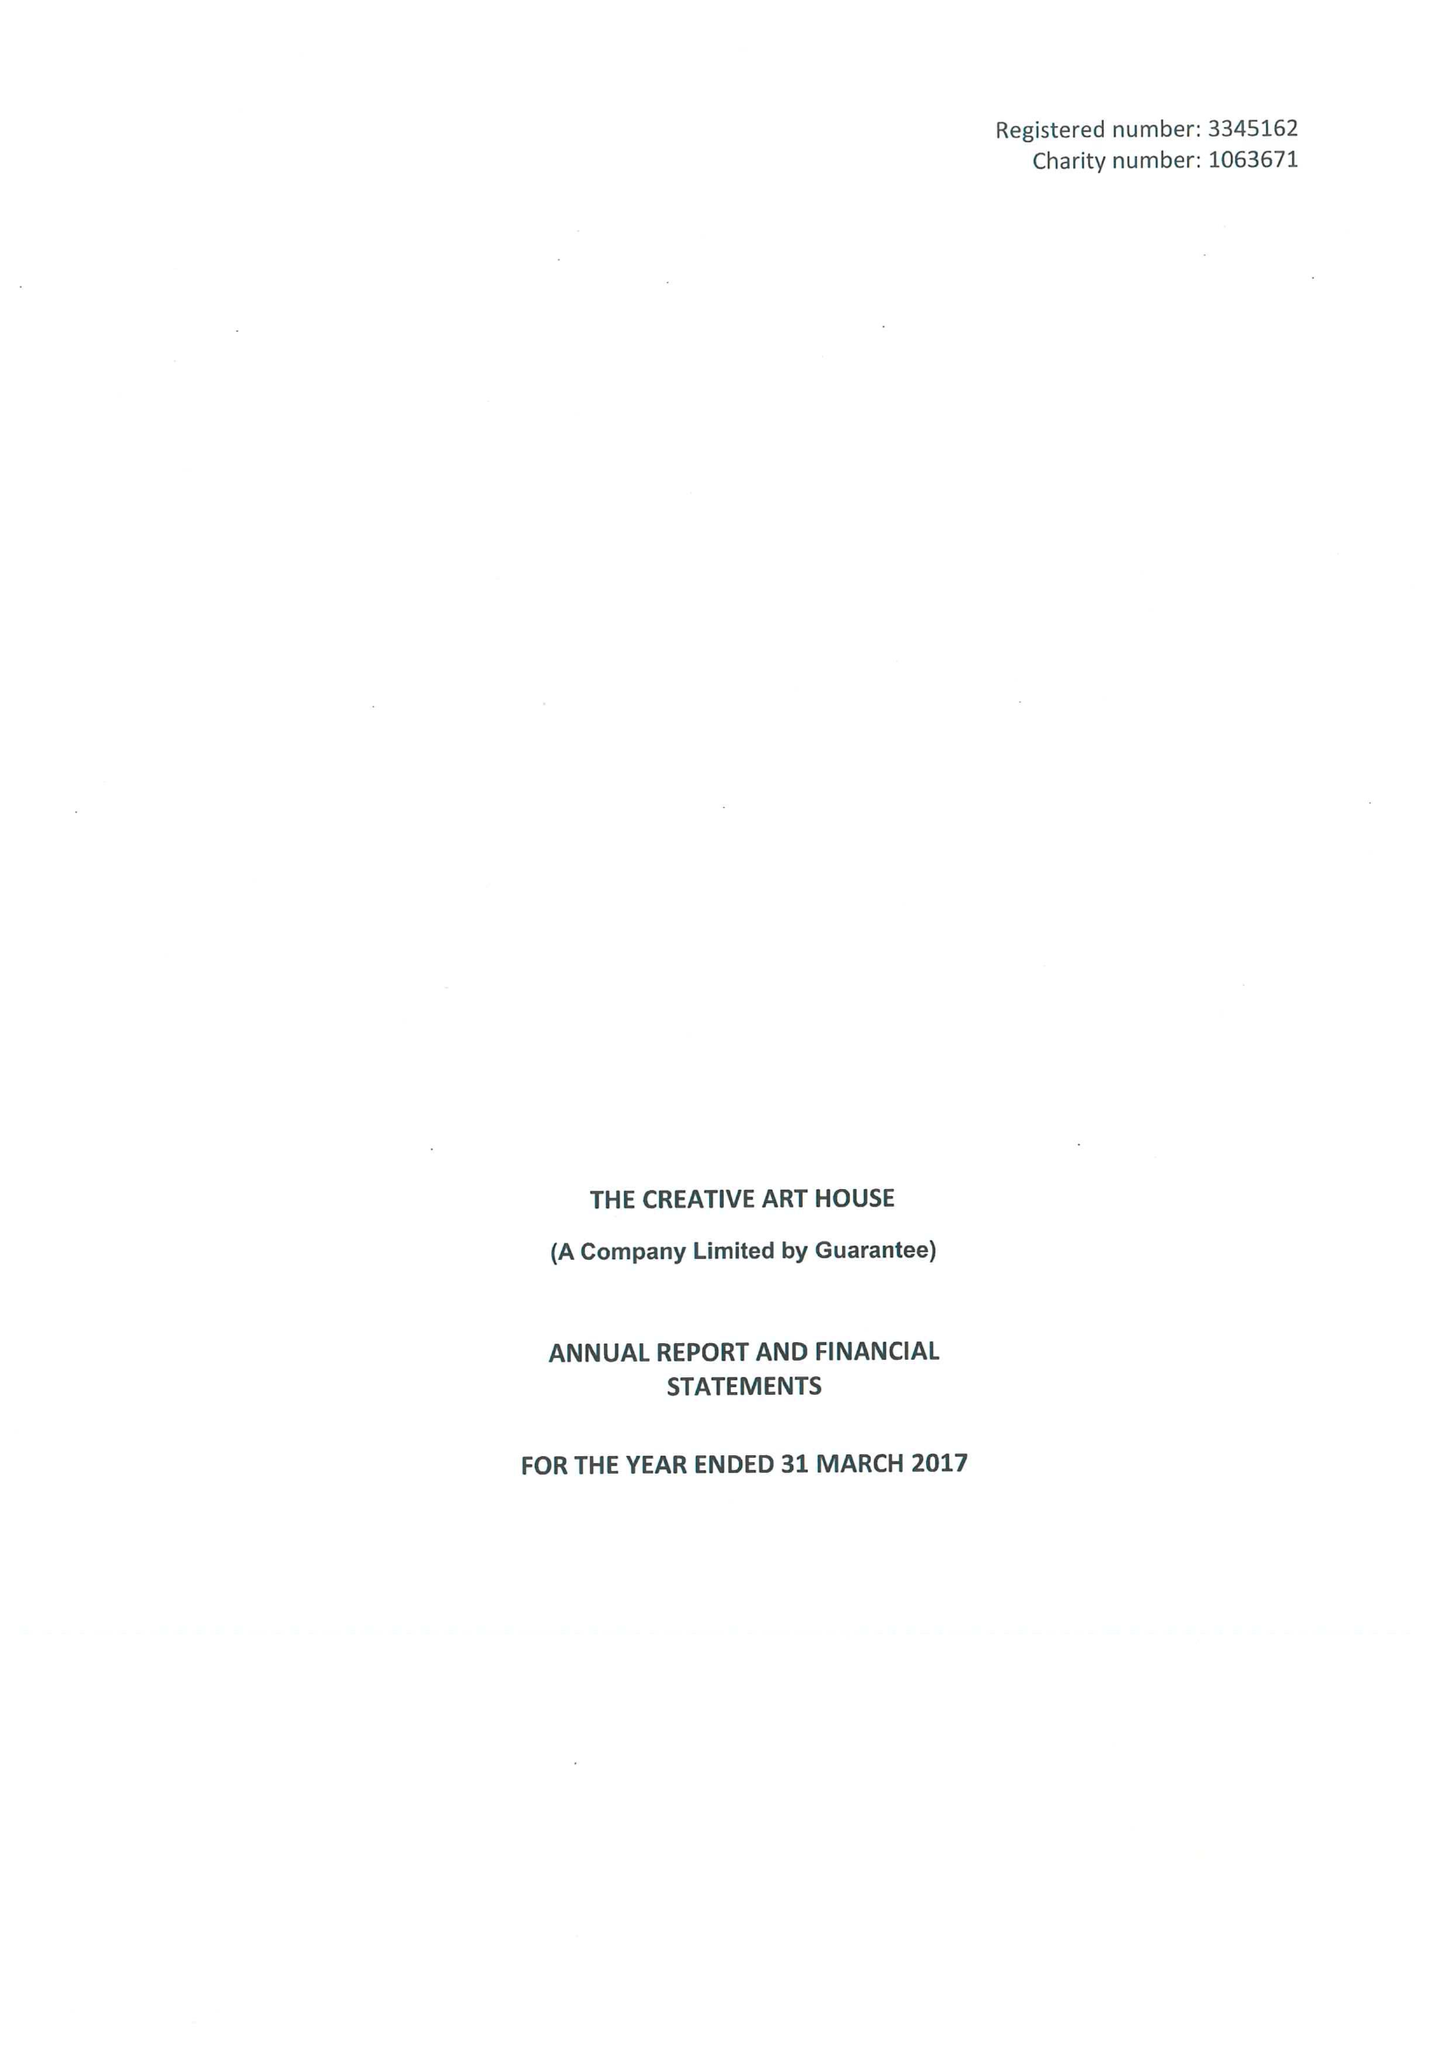What is the value for the address__street_line?
Answer the question using a single word or phrase. DRURY LANE 